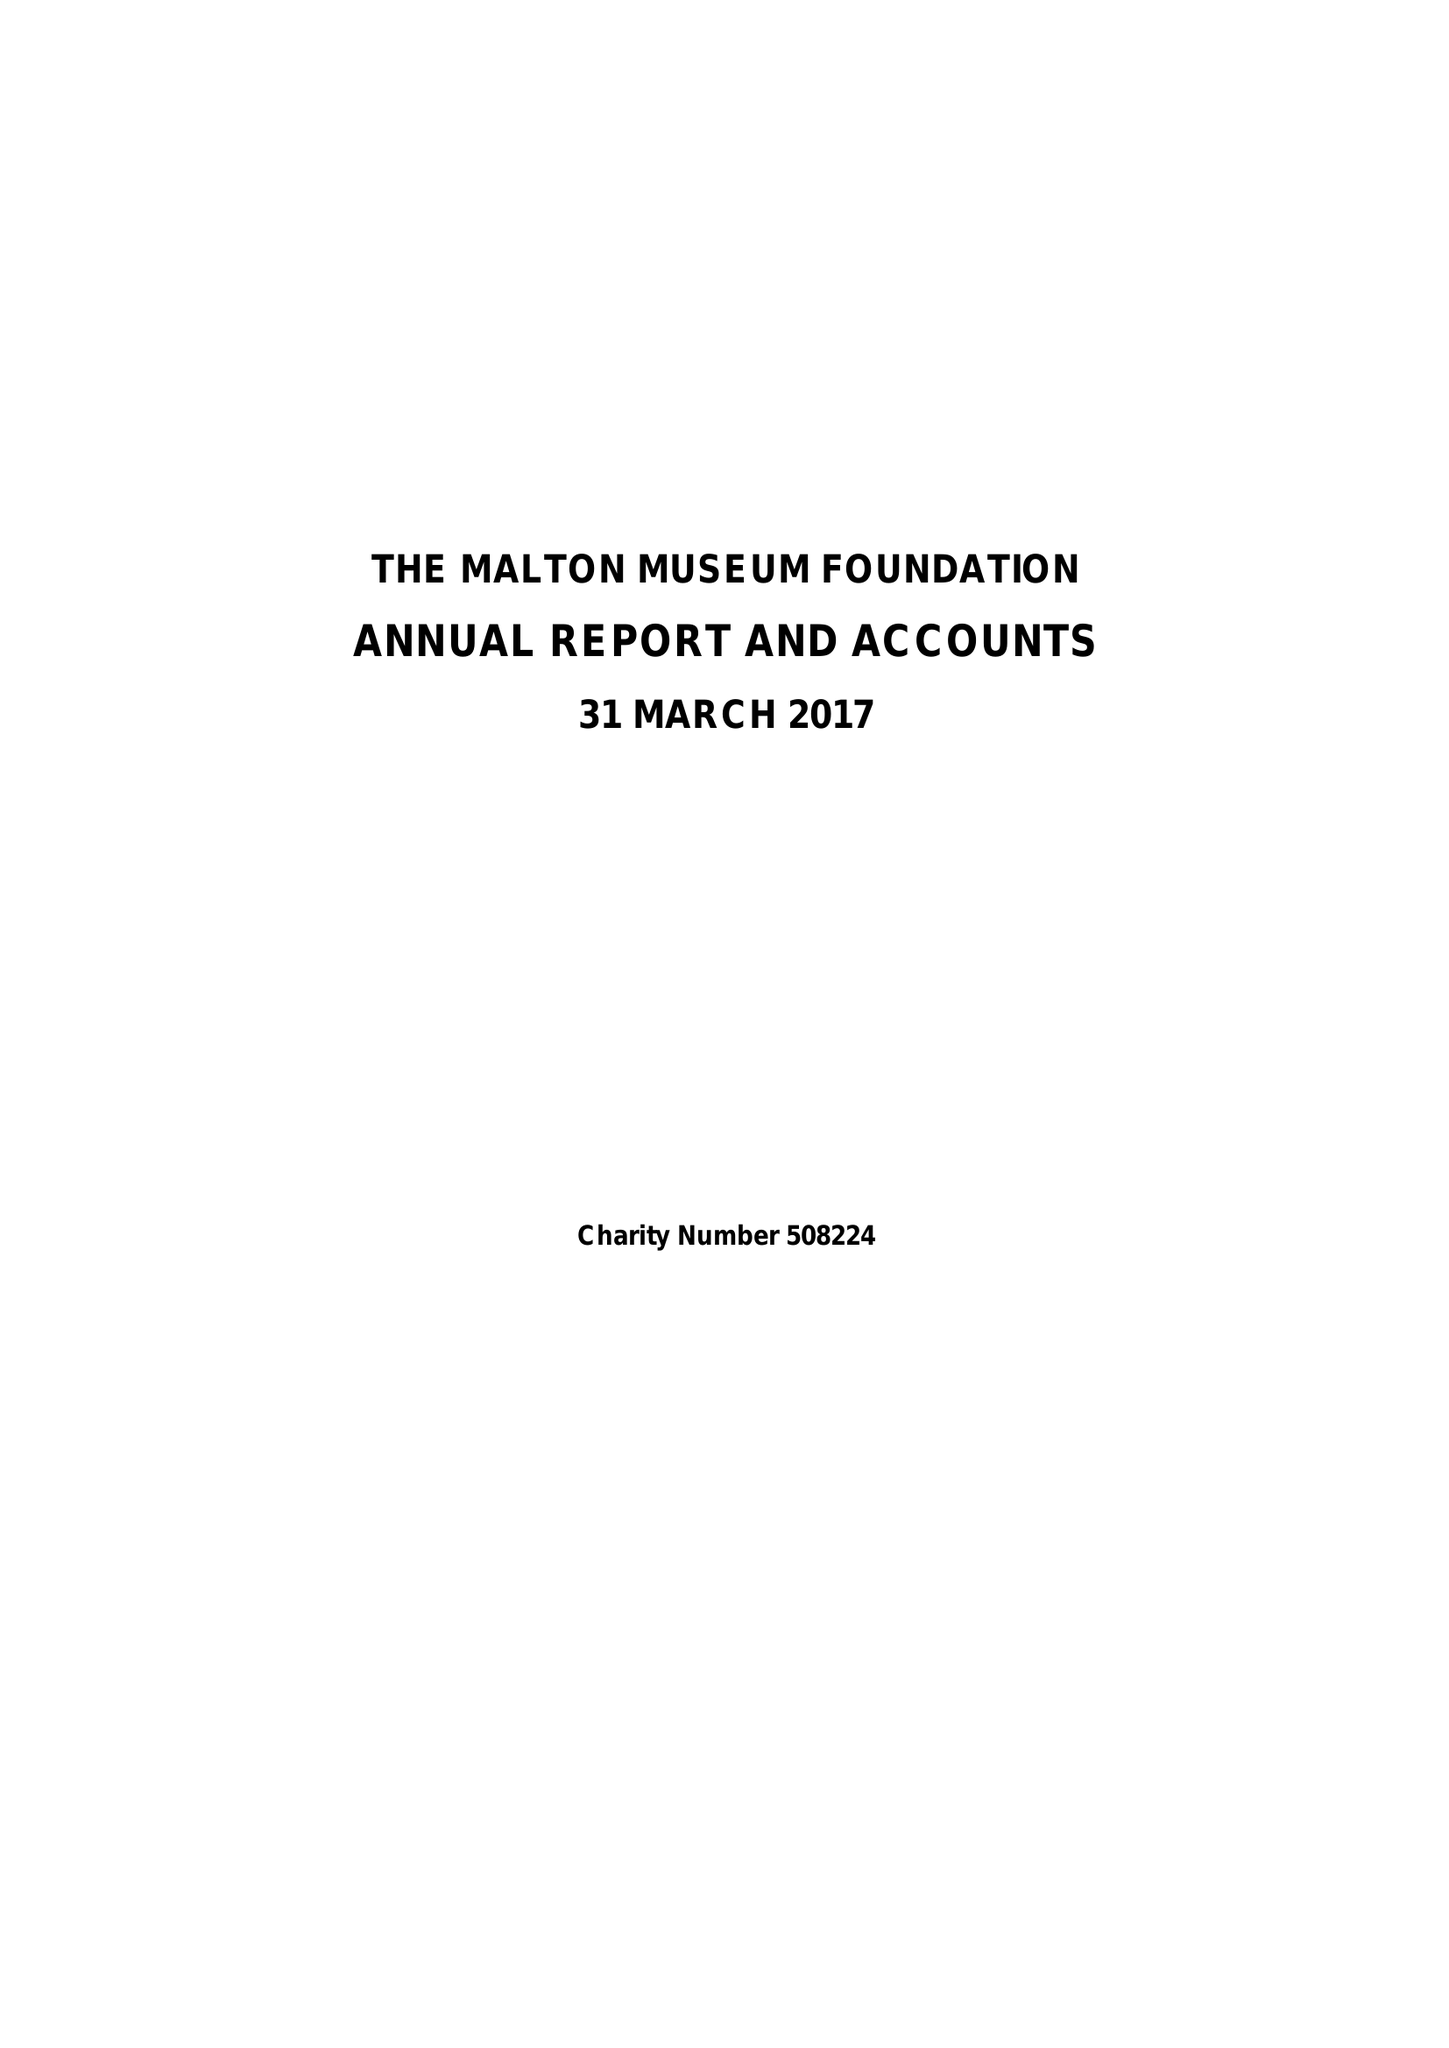What is the value for the address__post_town?
Answer the question using a single word or phrase. MALTON 